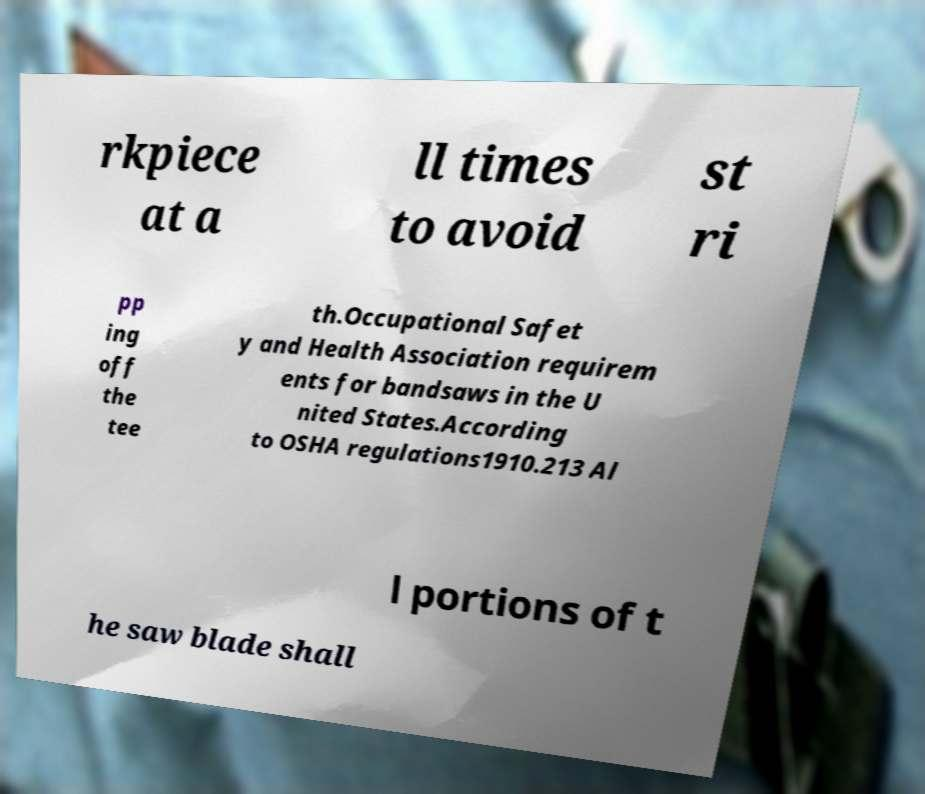For documentation purposes, I need the text within this image transcribed. Could you provide that? rkpiece at a ll times to avoid st ri pp ing off the tee th.Occupational Safet y and Health Association requirem ents for bandsaws in the U nited States.According to OSHA regulations1910.213 Al l portions of t he saw blade shall 